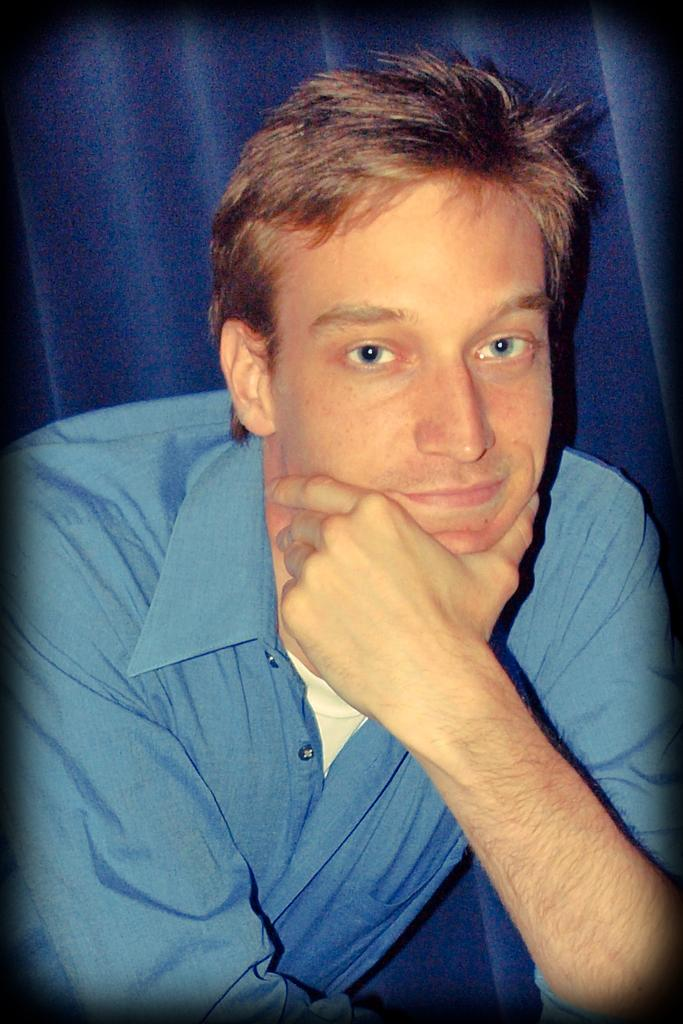What is present in the image? There is a man in the image. Can you describe the background of the image? There is a curtain in the background of the image. What type of collar can be seen on the man in the image? There is no collar visible on the man in the image. What kind of slope is present in the image? There is no slope present in the image; it only features a man and a curtain. 